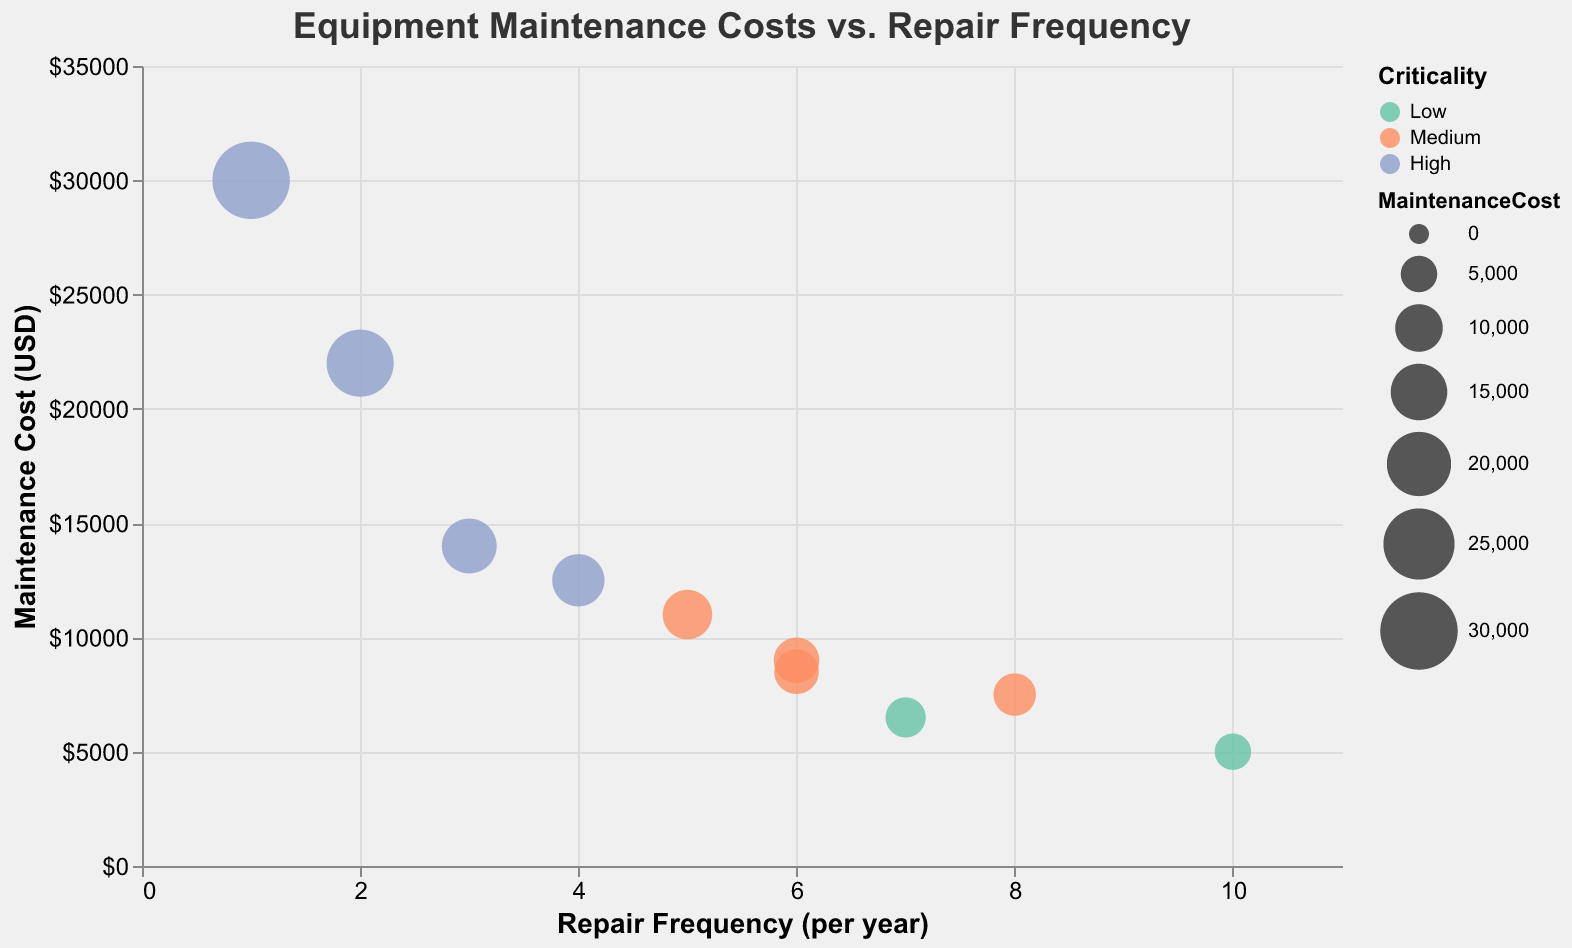What is the title of the figure? The figure's text title is present at the top in bold and reads "Equipment Maintenance Costs vs. Repair Frequency".
Answer: Equipment Maintenance Costs vs. Repair Frequency What is the maintenance cost of the Electric Arc Furnace? Hovering over the bubble representing the Electric Arc Furnace in the tooltip shows its maintenance cost.
Answer: $30,000 How many components have a high criticality? The color legend indicates the criticality levels. By counting the bubbles colored for 'High' criticality, we see that there are 4 components.
Answer: 4 Which component has the highest repair frequency? The x-axis represents repair frequency. The rightmost bubble on this axis represents the Water Pump, with a repair frequency of 10.
Answer: Water Pump Which component has the lowest maintenance cost? The y-axis represents maintenance cost. The lowest bubble with the least y-value indicates the Water Pump.
Answer: Water Pump What is the average maintenance cost for components with medium criticality? Identify the components with medium criticality from the color and sum their maintenance costs (Cooling System: 9000, Conveyor Belt: 7500, Crane System: 11000, Dust Collector: 8500). Sum total is (9000 + 7500 + 11000 + 8500) = 36000 and there are 4 components, so average = 36000 / 4.
Answer: $9,000 Which component has a higher maintenance cost: the Blast Furnace or the Hydraulic Press? Compare the y-axis values of the Blast Furnace (22,000) and the Hydraulic Press (14,000). The Blast Furnace is higher.
Answer: Blast Furnace What's the median repair frequency of all components? List out frequencies: (1, 2, 3, 4, 5, 6, 6, 7, 8, 10). The median is the middle value, with 10 values, median is between the 5th and 6th values. (5 + 6) / 2 = 5.5
Answer: 5.5 Which color represents low criticality? The color legend shows that the color representation for low criticality is light green.
Answer: Light Green 